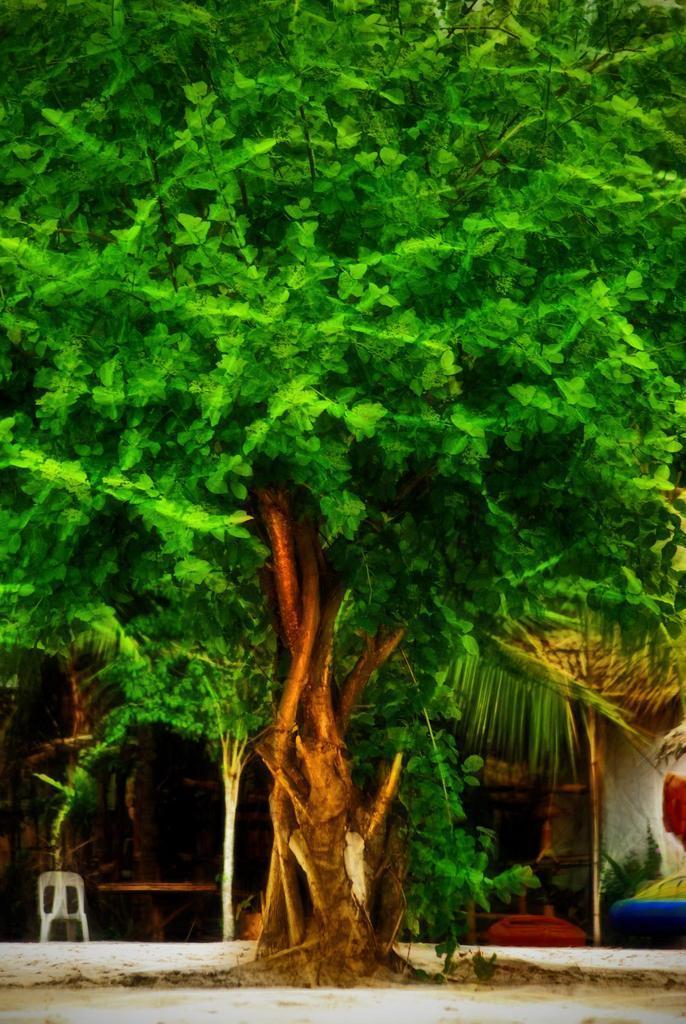Could you give a brief overview of what you see in this image? In this image I can see a tree on the ground. On the right side there is a wall. On the left side there is a chair. 